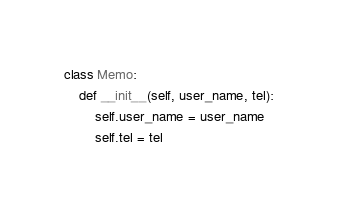Convert code to text. <code><loc_0><loc_0><loc_500><loc_500><_Python_>class Memo:
    def __init__(self, user_name, tel):
        self.user_name = user_name
        self.tel = tel


</code> 